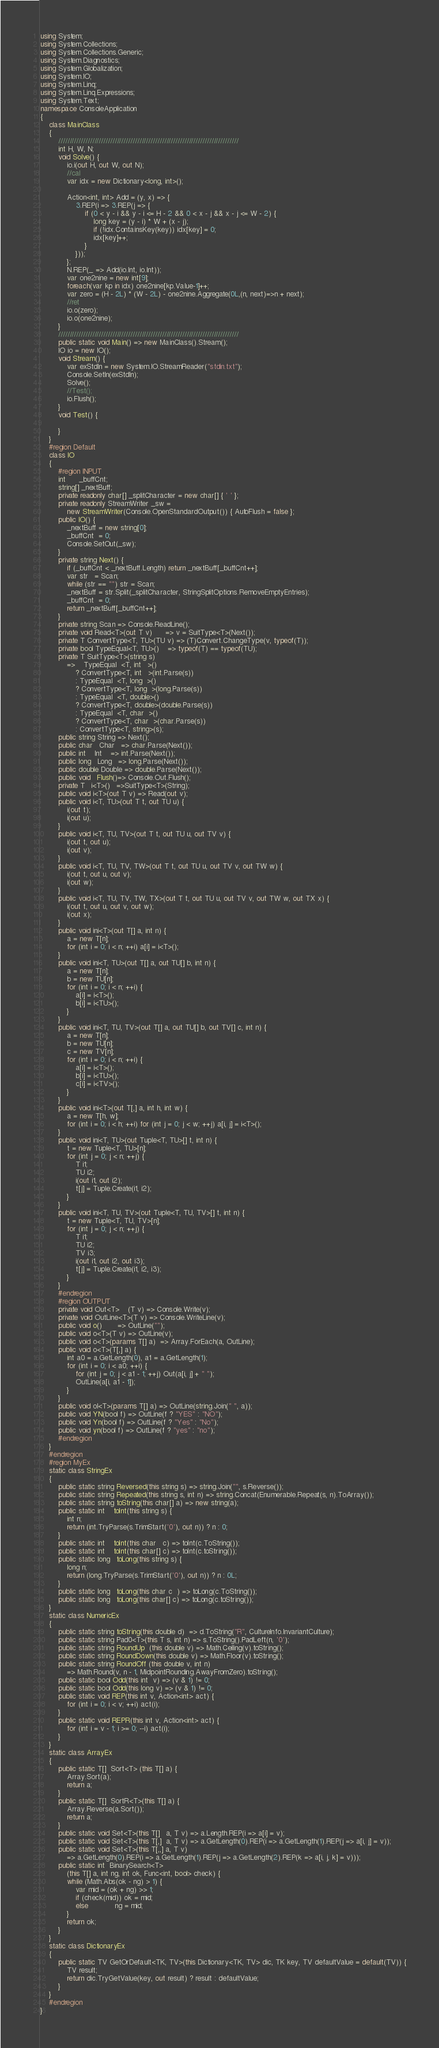<code> <loc_0><loc_0><loc_500><loc_500><_C#_>using System;
using System.Collections;
using System.Collections.Generic;
using System.Diagnostics;
using System.Globalization;
using System.IO;
using System.Linq;
using System.Linq.Expressions;
using System.Text;
namespace ConsoleApplication
{
    class MainClass
    {
        ////////////////////////////////////////////////////////////////////////////////        
        int H, W, N;
        void Solve() {
            io.i(out H, out W, out N);
            //cal
            var idx = new Dictionary<long, int>();

            Action<int, int> Add = (y, x) => {
                3.REP(i => 3.REP(j => {
                    if (0 < y - i && y - i <= H - 2 && 0 < x - j && x - j <= W - 2) {
                        long key = (y - i) * W + (x - j);
                        if (!idx.ContainsKey(key)) idx[key] = 0;
                        idx[key]++;
                    }
                }));
            };
            N.REP(_ => Add(io.Int, io.Int));
            var one2nine = new int[9];
            foreach(var kp in idx) one2nine[kp.Value-1]++;
            var zero = (H - 2L) * (W - 2L) - one2nine.Aggregate(0L,(n, next)=>n + next);
            //ret
            io.o(zero);
            io.o(one2nine);
        }
        ////////////////////////////////////////////////////////////////////////////////
        public static void Main() => new MainClass().Stream();
        IO io = new IO();
        void Stream() {
            var exStdIn = new System.IO.StreamReader("stdin.txt");
            Console.SetIn(exStdIn);
            Solve();
            //Test();
            io.Flush();
        }
        void Test() {

        }
    }
    #region Default
    class IO
    {
        #region INPUT
        int      _buffCnt;
        string[] _nextBuff;
        private readonly char[] _splitCharacter = new char[] { ' ' };
        private readonly StreamWriter _sw = 
            new StreamWriter(Console.OpenStandardOutput()) { AutoFlush = false };
        public IO() {
            _nextBuff = new string[0];
            _buffCnt  = 0;
            Console.SetOut(_sw);
        }
        private string Next() {
            if (_buffCnt < _nextBuff.Length) return _nextBuff[_buffCnt++];
            var str   = Scan;
            while (str == "") str = Scan;
            _nextBuff = str.Split(_splitCharacter, StringSplitOptions.RemoveEmptyEntries);
            _buffCnt  = 0;
            return _nextBuff[_buffCnt++];
        }
        private string Scan => Console.ReadLine();
        private void Read<T>(out T v)      => v = SuitType<T>(Next());
        private T ConvertType<T, TU>(TU v) => (T)Convert.ChangeType(v, typeof(T));
        private bool TypeEqual<T, TU>()    => typeof(T) == typeof(TU);
        private T SuitType<T>(string s)
            =>    TypeEqual  <T, int   >() 
                ? ConvertType<T, int   >(int.Parse(s))
                : TypeEqual  <T, long  >()
                ? ConvertType<T, long  >(long.Parse(s))
                : TypeEqual  <T, double>()
                ? ConvertType<T, double>(double.Parse(s))
                : TypeEqual  <T, char  >() 
                ? ConvertType<T, char  >(char.Parse(s)) 
                : ConvertType<T, string>(s);
        public string String => Next();
        public char   Char   => char.Parse(Next());
        public int    Int    => int.Parse(Next());
        public long   Long   => long.Parse(Next());
        public double Double => double.Parse(Next());
        public void   Flush()=> Console.Out.Flush();
        private T   i<T>()   =>SuitType<T>(String); 
        public void i<T>(out T v) => Read(out v);
        public void i<T, TU>(out T t, out TU u) {
            i(out t);
            i(out u);
        }
        public void i<T, TU, TV>(out T t, out TU u, out TV v) {
            i(out t, out u);
            i(out v);
        }
        public void i<T, TU, TV, TW>(out T t, out TU u, out TV v, out TW w) {
            i(out t, out u, out v);
            i(out w);
        }
        public void i<T, TU, TV, TW, TX>(out T t, out TU u, out TV v, out TW w, out TX x) {
            i(out t, out u, out v, out w);
            i(out x);
        }
        public void ini<T>(out T[] a, int n) {
            a = new T[n];
            for (int i = 0; i < n; ++i) a[i] = i<T>();
        }
        public void ini<T, TU>(out T[] a, out TU[] b, int n) {
            a = new T[n];
            b = new TU[n];
            for (int i = 0; i < n; ++i) {
                a[i] = i<T>();
                b[i] = i<TU>();
            }
        }
        public void ini<T, TU, TV>(out T[] a, out TU[] b, out TV[] c, int n) {
            a = new T[n];
            b = new TU[n];
            c = new TV[n];
            for (int i = 0; i < n; ++i) {
                a[i] = i<T>();
                b[i] = i<TU>();
                c[i] = i<TV>();
            }
        }
        public void ini<T>(out T[,] a, int h, int w) {
            a = new T[h, w];
            for (int i = 0; i < h; ++i) for (int j = 0; j < w; ++j) a[i, j] = i<T>();
        }
        public void ini<T, TU>(out Tuple<T, TU>[] t, int n) {
            t = new Tuple<T, TU>[n];
            for (int j = 0; j < n; ++j) {
                T i1;
                TU i2;
                i(out i1, out i2);
                t[j] = Tuple.Create(i1, i2);
            }
        }
        public void ini<T, TU, TV>(out Tuple<T, TU, TV>[] t, int n) {
            t = new Tuple<T, TU, TV>[n];
            for (int j = 0; j < n; ++j) {
                T i1;
                TU i2;
                TV i3;
                i(out i1, out i2, out i3);
                t[j] = Tuple.Create(i1, i2, i3);
            }
        }
        #endregion
        #region OUTPUT
        private void Out<T>    (T v) => Console.Write(v);
        private void OutLine<T>(T v) => Console.WriteLine(v);
        public void o()       => OutLine("");
        public void o<T>(T v) => OutLine(v);
        public void o<T>(params T[] a)  => Array.ForEach(a, OutLine);
        public void o<T>(T[,] a) {
            int a0 = a.GetLength(0), a1 = a.GetLength(1);
            for (int i = 0; i < a0; ++i) {
                for (int j = 0; j < a1 - 1; ++j) Out(a[i, j] + " ");
                OutLine(a[i, a1 - 1]);
            }
        }
        public void ol<T>(params T[] a) => OutLine(string.Join(" ", a));
        public void YN(bool f) => OutLine(f ? "YES" : "NO");
        public void Yn(bool f) => OutLine(f ? "Yes" : "No");
        public void yn(bool f) => OutLine(f ? "yes" : "no");
        #endregion
    }
    #endregion
    #region MyEx
    static class StringEx
    {
        public static string Reversed(this string s) => string.Join("", s.Reverse());
        public static string Repeated(this string s, int n) => string.Concat(Enumerable.Repeat(s, n).ToArray());
        public static string toString(this char[] a) => new string(a);
        public static int    toInt(this string s) {
            int n;
            return (int.TryParse(s.TrimStart('0'), out n)) ? n : 0;
        }
        public static int    toInt(this char   c) => toInt(c.ToString());
        public static int    toInt(this char[] c) => toInt(c.toString());
        public static long   toLong(this string s) {
            long n;
            return (long.TryParse(s.TrimStart('0'), out n)) ? n : 0L;
        }
        public static long   toLong(this char c  ) => toLong(c.ToString());
        public static long   toLong(this char[] c) => toLong(c.toString());
    }
    static class NumericEx
    {
        public static string toString(this double d)  => d.ToString("R", CultureInfo.InvariantCulture);
        public static string Pad0<T>(this T s, int n) => s.ToString().PadLeft(n, '0');
        public static string RoundUp  (this double v) => Math.Ceiling(v).toString();
        public static string RoundDown(this double v) => Math.Floor(v).toString();
        public static string RoundOff (this double v, int n)
            => Math.Round(v, n - 1, MidpointRounding.AwayFromZero).toString();
        public static bool Odd(this int  v) => (v & 1) != 0;
        public static bool Odd(this long v) => (v & 1) != 0;
        public static void REP(this int v, Action<int> act) {
            for (int i = 0; i < v; ++i) act(i);
        }
        public static void REPR(this int v, Action<int> act) {
            for (int i = v - 1; i >= 0; --i) act(i);
        }
    }
    static class ArrayEx
    {
        public static T[]  Sort<T> (this T[] a) {
            Array.Sort(a);
            return a;
        }
        public static T[]  SortR<T>(this T[] a) {
            Array.Reverse(a.Sort());
            return a;
        }
        public static void Set<T>(this T[]   a, T v) => a.Length.REP(i => a[i] = v);
        public static void Set<T>(this T[,]  a, T v) => a.GetLength(0).REP(i => a.GetLength(1).REP(j => a[i, j] = v));
        public static void Set<T>(this T[,,] a, T v)
            => a.GetLength(0).REP(i => a.GetLength(1).REP(j => a.GetLength(2).REP(k => a[i, j, k] = v)));
        public static int  BinarySearch<T>
            (this T[] a, int ng, int ok, Func<int, bool> check) {
            while (Math.Abs(ok - ng) > 1) {
                var mid = (ok + ng) >> 1;
                if (check(mid)) ok = mid;
                else            ng = mid;
            }
            return ok;
        }
    }
    static class DictionaryEx
    {
        public static TV GetOrDefault<TK, TV>(this Dictionary<TK, TV> dic, TK key, TV defaultValue = default(TV)) {
            TV result;
            return dic.TryGetValue(key, out result) ? result : defaultValue;
        }
    }
    #endregion
}</code> 